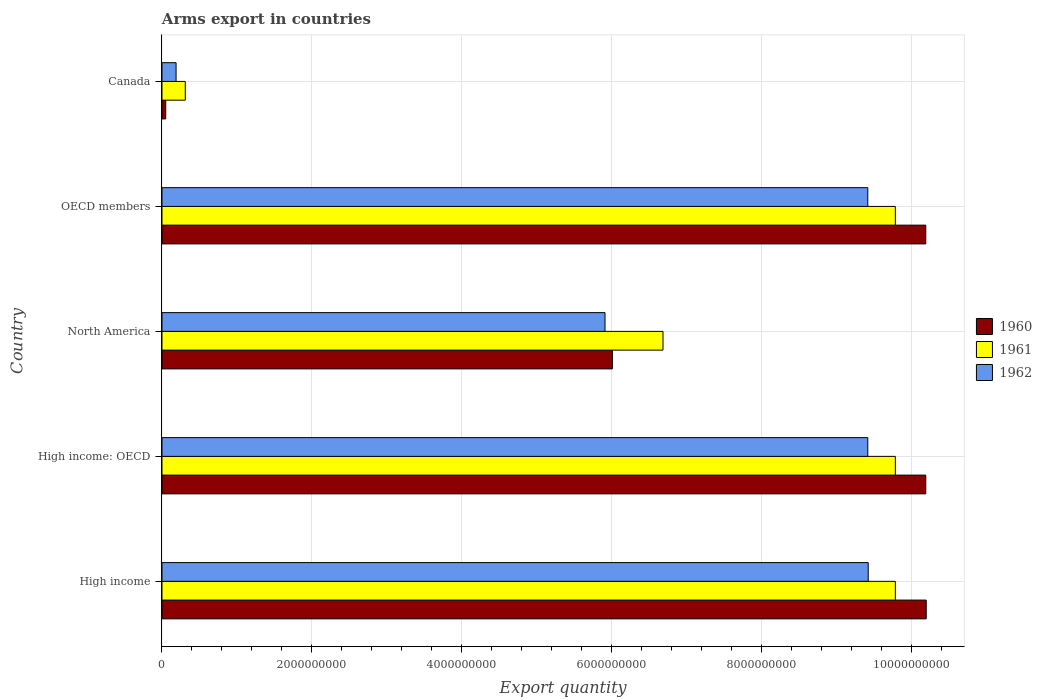How many groups of bars are there?
Make the answer very short. 5. How many bars are there on the 4th tick from the top?
Make the answer very short. 3. How many bars are there on the 3rd tick from the bottom?
Provide a short and direct response. 3. What is the label of the 2nd group of bars from the top?
Make the answer very short. OECD members. What is the total arms export in 1960 in North America?
Offer a very short reply. 6.01e+09. Across all countries, what is the maximum total arms export in 1962?
Ensure brevity in your answer.  9.43e+09. Across all countries, what is the minimum total arms export in 1961?
Offer a terse response. 3.11e+08. What is the total total arms export in 1960 in the graph?
Keep it short and to the point. 3.66e+1. What is the difference between the total arms export in 1960 in High income: OECD and the total arms export in 1962 in North America?
Offer a terse response. 4.28e+09. What is the average total arms export in 1960 per country?
Offer a very short reply. 7.33e+09. What is the difference between the total arms export in 1961 and total arms export in 1960 in North America?
Provide a succinct answer. 6.76e+08. In how many countries, is the total arms export in 1961 greater than 5600000000 ?
Your response must be concise. 4. Is the total arms export in 1961 in North America less than that in OECD members?
Offer a terse response. Yes. Is the difference between the total arms export in 1961 in North America and OECD members greater than the difference between the total arms export in 1960 in North America and OECD members?
Provide a succinct answer. Yes. What is the difference between the highest and the second highest total arms export in 1961?
Give a very brief answer. 0. What is the difference between the highest and the lowest total arms export in 1962?
Keep it short and to the point. 9.24e+09. In how many countries, is the total arms export in 1960 greater than the average total arms export in 1960 taken over all countries?
Provide a succinct answer. 3. Is it the case that in every country, the sum of the total arms export in 1960 and total arms export in 1961 is greater than the total arms export in 1962?
Make the answer very short. Yes. How many countries are there in the graph?
Provide a succinct answer. 5. Are the values on the major ticks of X-axis written in scientific E-notation?
Give a very brief answer. No. Does the graph contain any zero values?
Your answer should be compact. No. Does the graph contain grids?
Offer a terse response. Yes. Where does the legend appear in the graph?
Give a very brief answer. Center right. How are the legend labels stacked?
Provide a short and direct response. Vertical. What is the title of the graph?
Your answer should be compact. Arms export in countries. Does "2009" appear as one of the legend labels in the graph?
Your response must be concise. No. What is the label or title of the X-axis?
Your answer should be very brief. Export quantity. What is the Export quantity of 1960 in High income?
Provide a succinct answer. 1.02e+1. What is the Export quantity in 1961 in High income?
Your answer should be compact. 9.79e+09. What is the Export quantity of 1962 in High income?
Offer a very short reply. 9.43e+09. What is the Export quantity in 1960 in High income: OECD?
Make the answer very short. 1.02e+1. What is the Export quantity of 1961 in High income: OECD?
Provide a succinct answer. 9.79e+09. What is the Export quantity in 1962 in High income: OECD?
Provide a short and direct response. 9.42e+09. What is the Export quantity in 1960 in North America?
Give a very brief answer. 6.01e+09. What is the Export quantity of 1961 in North America?
Provide a succinct answer. 6.69e+09. What is the Export quantity in 1962 in North America?
Offer a terse response. 5.91e+09. What is the Export quantity in 1960 in OECD members?
Provide a succinct answer. 1.02e+1. What is the Export quantity in 1961 in OECD members?
Keep it short and to the point. 9.79e+09. What is the Export quantity of 1962 in OECD members?
Keep it short and to the point. 9.42e+09. What is the Export quantity of 1960 in Canada?
Offer a very short reply. 5.00e+07. What is the Export quantity in 1961 in Canada?
Your answer should be compact. 3.11e+08. What is the Export quantity of 1962 in Canada?
Your answer should be compact. 1.88e+08. Across all countries, what is the maximum Export quantity of 1960?
Ensure brevity in your answer.  1.02e+1. Across all countries, what is the maximum Export quantity in 1961?
Offer a very short reply. 9.79e+09. Across all countries, what is the maximum Export quantity in 1962?
Your response must be concise. 9.43e+09. Across all countries, what is the minimum Export quantity in 1960?
Ensure brevity in your answer.  5.00e+07. Across all countries, what is the minimum Export quantity of 1961?
Your answer should be compact. 3.11e+08. Across all countries, what is the minimum Export quantity of 1962?
Your answer should be very brief. 1.88e+08. What is the total Export quantity of 1960 in the graph?
Give a very brief answer. 3.66e+1. What is the total Export quantity in 1961 in the graph?
Provide a short and direct response. 3.64e+1. What is the total Export quantity in 1962 in the graph?
Keep it short and to the point. 3.44e+1. What is the difference between the Export quantity in 1961 in High income and that in High income: OECD?
Ensure brevity in your answer.  0. What is the difference between the Export quantity of 1960 in High income and that in North America?
Provide a succinct answer. 4.19e+09. What is the difference between the Export quantity in 1961 in High income and that in North America?
Offer a very short reply. 3.10e+09. What is the difference between the Export quantity of 1962 in High income and that in North America?
Make the answer very short. 3.51e+09. What is the difference between the Export quantity in 1960 in High income and that in OECD members?
Your answer should be compact. 6.00e+06. What is the difference between the Export quantity in 1960 in High income and that in Canada?
Your response must be concise. 1.02e+1. What is the difference between the Export quantity of 1961 in High income and that in Canada?
Offer a terse response. 9.48e+09. What is the difference between the Export quantity in 1962 in High income and that in Canada?
Provide a short and direct response. 9.24e+09. What is the difference between the Export quantity in 1960 in High income: OECD and that in North America?
Keep it short and to the point. 4.18e+09. What is the difference between the Export quantity of 1961 in High income: OECD and that in North America?
Offer a terse response. 3.10e+09. What is the difference between the Export quantity of 1962 in High income: OECD and that in North America?
Provide a short and direct response. 3.51e+09. What is the difference between the Export quantity of 1960 in High income: OECD and that in OECD members?
Your answer should be compact. 0. What is the difference between the Export quantity in 1960 in High income: OECD and that in Canada?
Provide a short and direct response. 1.01e+1. What is the difference between the Export quantity in 1961 in High income: OECD and that in Canada?
Keep it short and to the point. 9.48e+09. What is the difference between the Export quantity in 1962 in High income: OECD and that in Canada?
Ensure brevity in your answer.  9.23e+09. What is the difference between the Export quantity of 1960 in North America and that in OECD members?
Offer a terse response. -4.18e+09. What is the difference between the Export quantity of 1961 in North America and that in OECD members?
Keep it short and to the point. -3.10e+09. What is the difference between the Export quantity in 1962 in North America and that in OECD members?
Provide a succinct answer. -3.51e+09. What is the difference between the Export quantity of 1960 in North America and that in Canada?
Provide a short and direct response. 5.96e+09. What is the difference between the Export quantity in 1961 in North America and that in Canada?
Keep it short and to the point. 6.38e+09. What is the difference between the Export quantity of 1962 in North America and that in Canada?
Give a very brief answer. 5.72e+09. What is the difference between the Export quantity of 1960 in OECD members and that in Canada?
Your answer should be very brief. 1.01e+1. What is the difference between the Export quantity of 1961 in OECD members and that in Canada?
Ensure brevity in your answer.  9.48e+09. What is the difference between the Export quantity of 1962 in OECD members and that in Canada?
Your answer should be very brief. 9.23e+09. What is the difference between the Export quantity in 1960 in High income and the Export quantity in 1961 in High income: OECD?
Make the answer very short. 4.12e+08. What is the difference between the Export quantity of 1960 in High income and the Export quantity of 1962 in High income: OECD?
Offer a terse response. 7.80e+08. What is the difference between the Export quantity of 1961 in High income and the Export quantity of 1962 in High income: OECD?
Keep it short and to the point. 3.68e+08. What is the difference between the Export quantity in 1960 in High income and the Export quantity in 1961 in North America?
Give a very brief answer. 3.51e+09. What is the difference between the Export quantity in 1960 in High income and the Export quantity in 1962 in North America?
Make the answer very short. 4.29e+09. What is the difference between the Export quantity in 1961 in High income and the Export quantity in 1962 in North America?
Ensure brevity in your answer.  3.88e+09. What is the difference between the Export quantity of 1960 in High income and the Export quantity of 1961 in OECD members?
Your response must be concise. 4.12e+08. What is the difference between the Export quantity of 1960 in High income and the Export quantity of 1962 in OECD members?
Your answer should be compact. 7.80e+08. What is the difference between the Export quantity in 1961 in High income and the Export quantity in 1962 in OECD members?
Provide a succinct answer. 3.68e+08. What is the difference between the Export quantity in 1960 in High income and the Export quantity in 1961 in Canada?
Provide a succinct answer. 9.89e+09. What is the difference between the Export quantity in 1960 in High income and the Export quantity in 1962 in Canada?
Provide a succinct answer. 1.00e+1. What is the difference between the Export quantity in 1961 in High income and the Export quantity in 1962 in Canada?
Ensure brevity in your answer.  9.60e+09. What is the difference between the Export quantity of 1960 in High income: OECD and the Export quantity of 1961 in North America?
Provide a short and direct response. 3.51e+09. What is the difference between the Export quantity in 1960 in High income: OECD and the Export quantity in 1962 in North America?
Your answer should be very brief. 4.28e+09. What is the difference between the Export quantity of 1961 in High income: OECD and the Export quantity of 1962 in North America?
Make the answer very short. 3.88e+09. What is the difference between the Export quantity in 1960 in High income: OECD and the Export quantity in 1961 in OECD members?
Offer a very short reply. 4.06e+08. What is the difference between the Export quantity in 1960 in High income: OECD and the Export quantity in 1962 in OECD members?
Ensure brevity in your answer.  7.74e+08. What is the difference between the Export quantity in 1961 in High income: OECD and the Export quantity in 1962 in OECD members?
Your answer should be compact. 3.68e+08. What is the difference between the Export quantity of 1960 in High income: OECD and the Export quantity of 1961 in Canada?
Provide a short and direct response. 9.88e+09. What is the difference between the Export quantity in 1960 in High income: OECD and the Export quantity in 1962 in Canada?
Your answer should be compact. 1.00e+1. What is the difference between the Export quantity of 1961 in High income: OECD and the Export quantity of 1962 in Canada?
Provide a succinct answer. 9.60e+09. What is the difference between the Export quantity of 1960 in North America and the Export quantity of 1961 in OECD members?
Ensure brevity in your answer.  -3.78e+09. What is the difference between the Export quantity of 1960 in North America and the Export quantity of 1962 in OECD members?
Ensure brevity in your answer.  -3.41e+09. What is the difference between the Export quantity in 1961 in North America and the Export quantity in 1962 in OECD members?
Your response must be concise. -2.73e+09. What is the difference between the Export quantity of 1960 in North America and the Export quantity of 1961 in Canada?
Your answer should be very brief. 5.70e+09. What is the difference between the Export quantity of 1960 in North America and the Export quantity of 1962 in Canada?
Provide a succinct answer. 5.82e+09. What is the difference between the Export quantity in 1961 in North America and the Export quantity in 1962 in Canada?
Provide a short and direct response. 6.50e+09. What is the difference between the Export quantity of 1960 in OECD members and the Export quantity of 1961 in Canada?
Provide a short and direct response. 9.88e+09. What is the difference between the Export quantity of 1960 in OECD members and the Export quantity of 1962 in Canada?
Provide a succinct answer. 1.00e+1. What is the difference between the Export quantity in 1961 in OECD members and the Export quantity in 1962 in Canada?
Ensure brevity in your answer.  9.60e+09. What is the average Export quantity of 1960 per country?
Offer a terse response. 7.33e+09. What is the average Export quantity of 1961 per country?
Keep it short and to the point. 7.27e+09. What is the average Export quantity of 1962 per country?
Give a very brief answer. 6.87e+09. What is the difference between the Export quantity of 1960 and Export quantity of 1961 in High income?
Provide a short and direct response. 4.12e+08. What is the difference between the Export quantity of 1960 and Export quantity of 1962 in High income?
Offer a very short reply. 7.74e+08. What is the difference between the Export quantity in 1961 and Export quantity in 1962 in High income?
Provide a succinct answer. 3.62e+08. What is the difference between the Export quantity of 1960 and Export quantity of 1961 in High income: OECD?
Give a very brief answer. 4.06e+08. What is the difference between the Export quantity of 1960 and Export quantity of 1962 in High income: OECD?
Give a very brief answer. 7.74e+08. What is the difference between the Export quantity in 1961 and Export quantity in 1962 in High income: OECD?
Provide a short and direct response. 3.68e+08. What is the difference between the Export quantity of 1960 and Export quantity of 1961 in North America?
Ensure brevity in your answer.  -6.76e+08. What is the difference between the Export quantity of 1960 and Export quantity of 1962 in North America?
Your answer should be compact. 9.80e+07. What is the difference between the Export quantity of 1961 and Export quantity of 1962 in North America?
Make the answer very short. 7.74e+08. What is the difference between the Export quantity of 1960 and Export quantity of 1961 in OECD members?
Offer a very short reply. 4.06e+08. What is the difference between the Export quantity in 1960 and Export quantity in 1962 in OECD members?
Ensure brevity in your answer.  7.74e+08. What is the difference between the Export quantity of 1961 and Export quantity of 1962 in OECD members?
Your answer should be compact. 3.68e+08. What is the difference between the Export quantity in 1960 and Export quantity in 1961 in Canada?
Make the answer very short. -2.61e+08. What is the difference between the Export quantity in 1960 and Export quantity in 1962 in Canada?
Your answer should be compact. -1.38e+08. What is the difference between the Export quantity of 1961 and Export quantity of 1962 in Canada?
Your response must be concise. 1.23e+08. What is the ratio of the Export quantity of 1960 in High income to that in High income: OECD?
Your answer should be compact. 1. What is the ratio of the Export quantity in 1962 in High income to that in High income: OECD?
Offer a very short reply. 1. What is the ratio of the Export quantity of 1960 in High income to that in North America?
Your answer should be compact. 1.7. What is the ratio of the Export quantity in 1961 in High income to that in North America?
Offer a terse response. 1.46. What is the ratio of the Export quantity in 1962 in High income to that in North America?
Keep it short and to the point. 1.59. What is the ratio of the Export quantity of 1960 in High income to that in Canada?
Ensure brevity in your answer.  204. What is the ratio of the Export quantity in 1961 in High income to that in Canada?
Ensure brevity in your answer.  31.47. What is the ratio of the Export quantity of 1962 in High income to that in Canada?
Keep it short and to the point. 50.14. What is the ratio of the Export quantity in 1960 in High income: OECD to that in North America?
Ensure brevity in your answer.  1.7. What is the ratio of the Export quantity of 1961 in High income: OECD to that in North America?
Provide a short and direct response. 1.46. What is the ratio of the Export quantity in 1962 in High income: OECD to that in North America?
Your answer should be compact. 1.59. What is the ratio of the Export quantity in 1960 in High income: OECD to that in OECD members?
Provide a short and direct response. 1. What is the ratio of the Export quantity in 1960 in High income: OECD to that in Canada?
Provide a short and direct response. 203.88. What is the ratio of the Export quantity of 1961 in High income: OECD to that in Canada?
Keep it short and to the point. 31.47. What is the ratio of the Export quantity in 1962 in High income: OECD to that in Canada?
Make the answer very short. 50.11. What is the ratio of the Export quantity in 1960 in North America to that in OECD members?
Your answer should be compact. 0.59. What is the ratio of the Export quantity in 1961 in North America to that in OECD members?
Offer a very short reply. 0.68. What is the ratio of the Export quantity in 1962 in North America to that in OECD members?
Provide a succinct answer. 0.63. What is the ratio of the Export quantity in 1960 in North America to that in Canada?
Make the answer very short. 120.22. What is the ratio of the Export quantity in 1961 in North America to that in Canada?
Provide a short and direct response. 21.5. What is the ratio of the Export quantity of 1962 in North America to that in Canada?
Provide a short and direct response. 31.45. What is the ratio of the Export quantity of 1960 in OECD members to that in Canada?
Your response must be concise. 203.88. What is the ratio of the Export quantity in 1961 in OECD members to that in Canada?
Offer a terse response. 31.47. What is the ratio of the Export quantity in 1962 in OECD members to that in Canada?
Your answer should be very brief. 50.11. What is the difference between the highest and the second highest Export quantity of 1961?
Keep it short and to the point. 0. What is the difference between the highest and the lowest Export quantity in 1960?
Offer a terse response. 1.02e+1. What is the difference between the highest and the lowest Export quantity of 1961?
Offer a terse response. 9.48e+09. What is the difference between the highest and the lowest Export quantity in 1962?
Provide a succinct answer. 9.24e+09. 